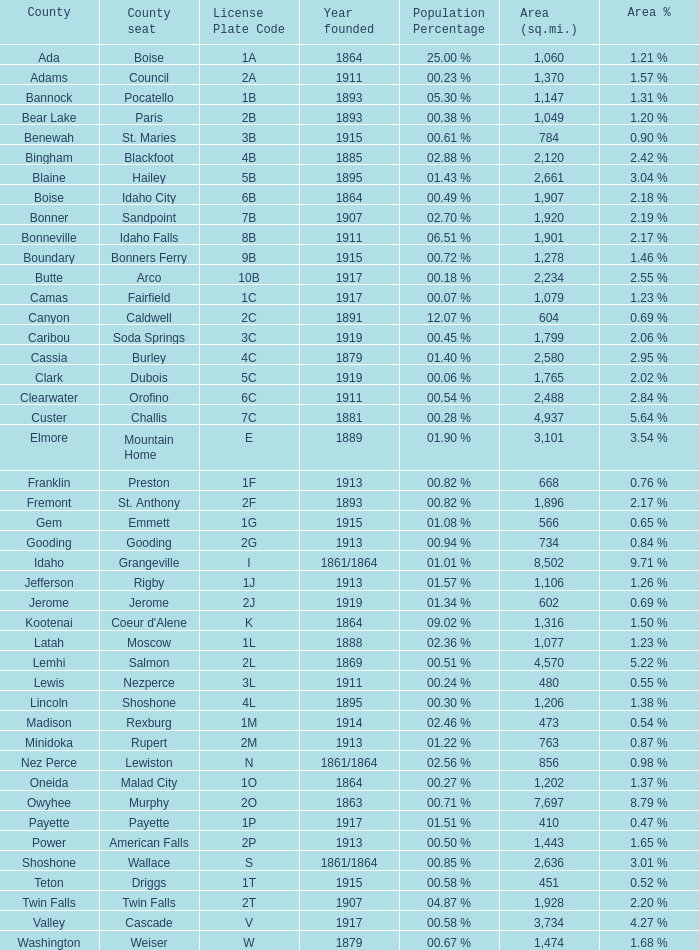I'm looking to parse the entire table for insights. Could you assist me with that? {'header': ['County', 'County seat', 'License Plate Code', 'Year founded', 'Population Percentage', 'Area (sq.mi.)', 'Area %'], 'rows': [['Ada', 'Boise', '1A', '1864', '25.00 %', '1,060', '1.21 %'], ['Adams', 'Council', '2A', '1911', '00.23 %', '1,370', '1.57 %'], ['Bannock', 'Pocatello', '1B', '1893', '05.30 %', '1,147', '1.31 %'], ['Bear Lake', 'Paris', '2B', '1893', '00.38 %', '1,049', '1.20 %'], ['Benewah', 'St. Maries', '3B', '1915', '00.61 %', '784', '0.90 %'], ['Bingham', 'Blackfoot', '4B', '1885', '02.88 %', '2,120', '2.42 %'], ['Blaine', 'Hailey', '5B', '1895', '01.43 %', '2,661', '3.04 %'], ['Boise', 'Idaho City', '6B', '1864', '00.49 %', '1,907', '2.18 %'], ['Bonner', 'Sandpoint', '7B', '1907', '02.70 %', '1,920', '2.19 %'], ['Bonneville', 'Idaho Falls', '8B', '1911', '06.51 %', '1,901', '2.17 %'], ['Boundary', 'Bonners Ferry', '9B', '1915', '00.72 %', '1,278', '1.46 %'], ['Butte', 'Arco', '10B', '1917', '00.18 %', '2,234', '2.55 %'], ['Camas', 'Fairfield', '1C', '1917', '00.07 %', '1,079', '1.23 %'], ['Canyon', 'Caldwell', '2C', '1891', '12.07 %', '604', '0.69 %'], ['Caribou', 'Soda Springs', '3C', '1919', '00.45 %', '1,799', '2.06 %'], ['Cassia', 'Burley', '4C', '1879', '01.40 %', '2,580', '2.95 %'], ['Clark', 'Dubois', '5C', '1919', '00.06 %', '1,765', '2.02 %'], ['Clearwater', 'Orofino', '6C', '1911', '00.54 %', '2,488', '2.84 %'], ['Custer', 'Challis', '7C', '1881', '00.28 %', '4,937', '5.64 %'], ['Elmore', 'Mountain Home', 'E', '1889', '01.90 %', '3,101', '3.54 %'], ['Franklin', 'Preston', '1F', '1913', '00.82 %', '668', '0.76 %'], ['Fremont', 'St. Anthony', '2F', '1893', '00.82 %', '1,896', '2.17 %'], ['Gem', 'Emmett', '1G', '1915', '01.08 %', '566', '0.65 %'], ['Gooding', 'Gooding', '2G', '1913', '00.94 %', '734', '0.84 %'], ['Idaho', 'Grangeville', 'I', '1861/1864', '01.01 %', '8,502', '9.71 %'], ['Jefferson', 'Rigby', '1J', '1913', '01.57 %', '1,106', '1.26 %'], ['Jerome', 'Jerome', '2J', '1919', '01.34 %', '602', '0.69 %'], ['Kootenai', "Coeur d'Alene", 'K', '1864', '09.02 %', '1,316', '1.50 %'], ['Latah', 'Moscow', '1L', '1888', '02.36 %', '1,077', '1.23 %'], ['Lemhi', 'Salmon', '2L', '1869', '00.51 %', '4,570', '5.22 %'], ['Lewis', 'Nezperce', '3L', '1911', '00.24 %', '480', '0.55 %'], ['Lincoln', 'Shoshone', '4L', '1895', '00.30 %', '1,206', '1.38 %'], ['Madison', 'Rexburg', '1M', '1914', '02.46 %', '473', '0.54 %'], ['Minidoka', 'Rupert', '2M', '1913', '01.22 %', '763', '0.87 %'], ['Nez Perce', 'Lewiston', 'N', '1861/1864', '02.56 %', '856', '0.98 %'], ['Oneida', 'Malad City', '1O', '1864', '00.27 %', '1,202', '1.37 %'], ['Owyhee', 'Murphy', '2O', '1863', '00.71 %', '7,697', '8.79 %'], ['Payette', 'Payette', '1P', '1917', '01.51 %', '410', '0.47 %'], ['Power', 'American Falls', '2P', '1913', '00.50 %', '1,443', '1.65 %'], ['Shoshone', 'Wallace', 'S', '1861/1864', '00.85 %', '2,636', '3.01 %'], ['Teton', 'Driggs', '1T', '1915', '00.58 %', '451', '0.52 %'], ['Twin Falls', 'Twin Falls', '2T', '1907', '04.87 %', '1,928', '2.20 %'], ['Valley', 'Cascade', 'V', '1917', '00.58 %', '3,734', '4.27 %'], ['Washington', 'Weiser', 'W', '1879', '00.67 %', '1,474', '1.68 %']]} What is the license plate code for the country with an area of 784? 3B. 